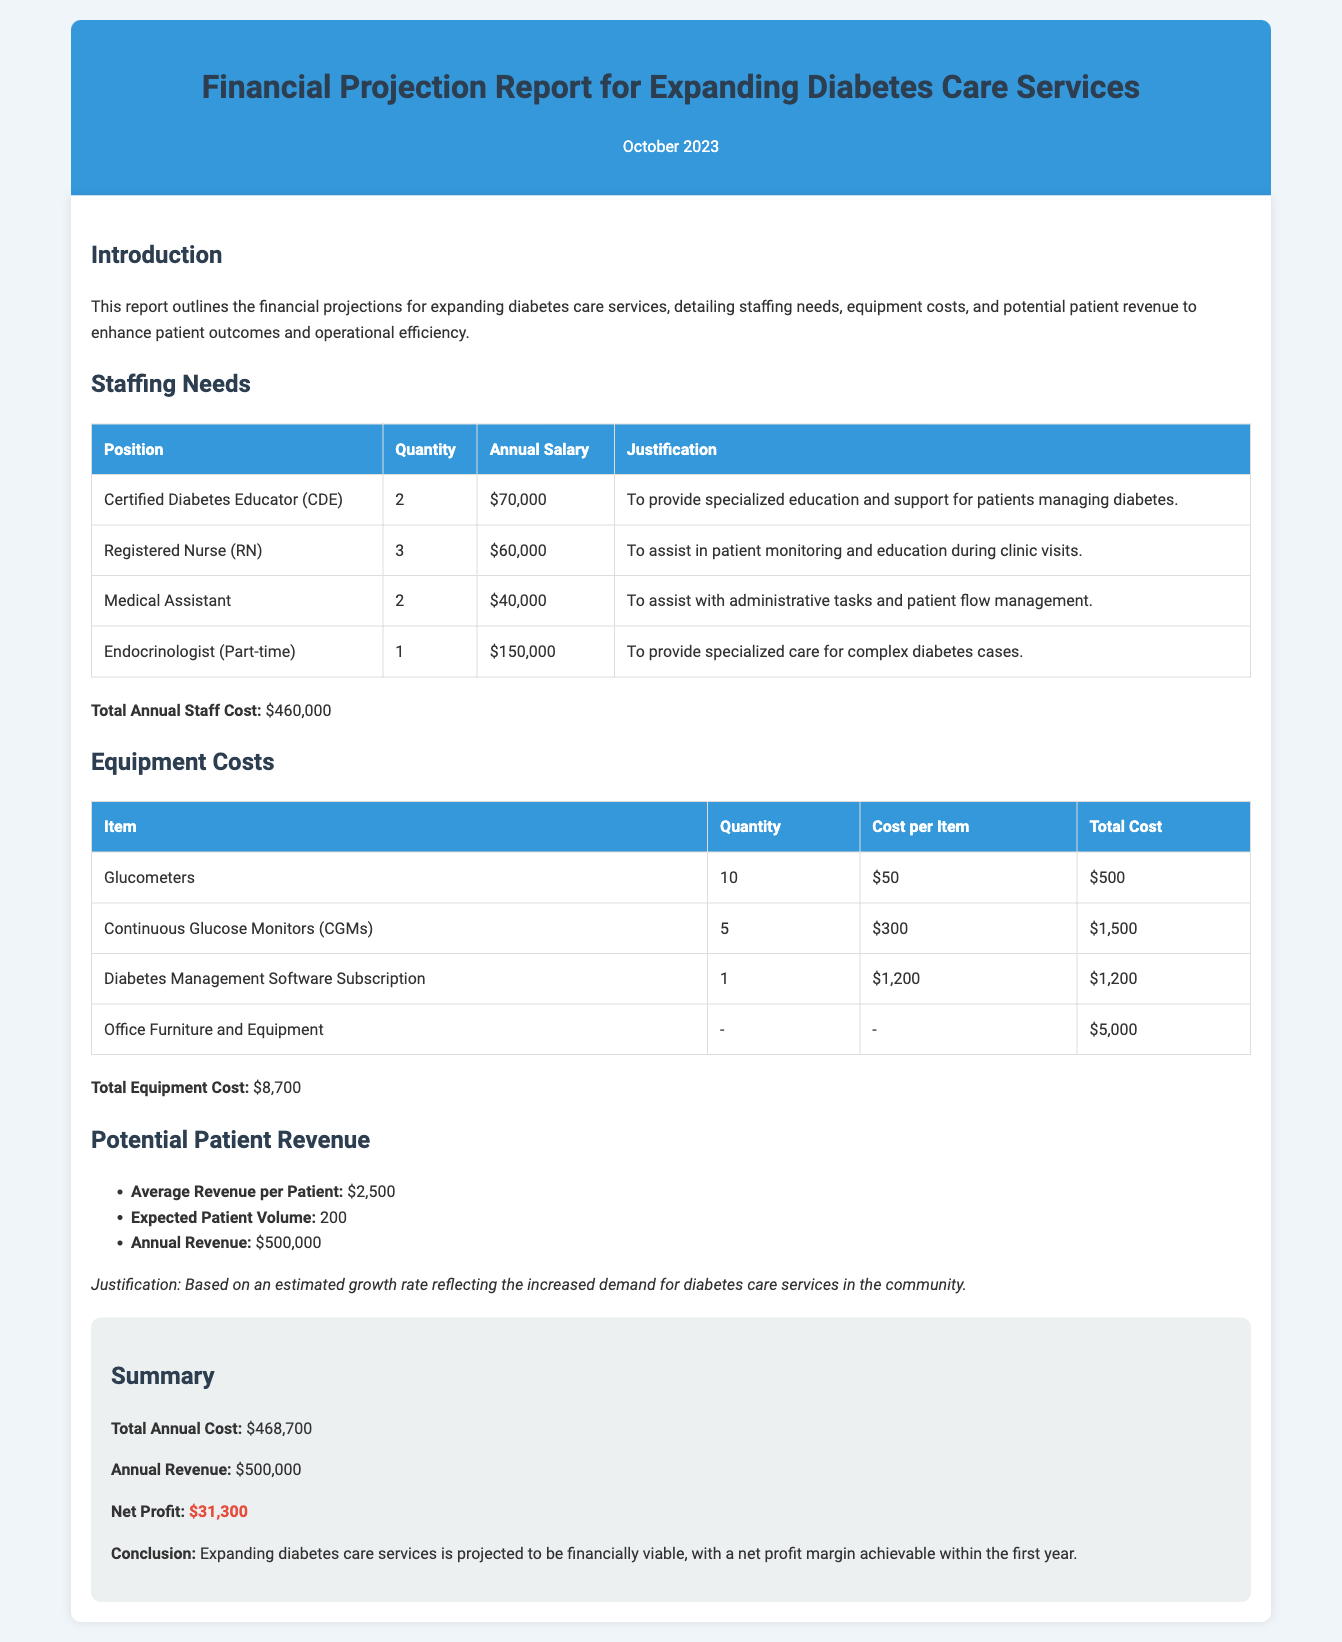What is the total annual staff cost? The total annual staff cost is calculated by adding the salaries of all staffing positions listed in the document.
Answer: $460,000 How many Certified Diabetes Educators are needed? The document states the quantity of Certified Diabetes Educators required for expanding diabetes care services.
Answer: 2 What is the total equipment cost? The total equipment cost is the sum of all individual equipment costs listed in the document.
Answer: $8,700 What is the expected annual revenue from patients? The expected annual revenue is stated directly in the potential patient revenue section of the document.
Answer: $500,000 What is the net profit projected for the first year? The net profit is calculated by subtracting the total annual cost from the annual revenue, as stated in the summary.
Answer: $31,300 What is the justification for hiring more staff? The justification for hiring staff is provided in the context of their roles and contributions to patient care and education.
Answer: To provide specialized education and support for patients managing diabetes How much does a Continuous Glucose Monitor cost? The cost of a Continuous Glucose Monitor is given as part of the equipment costs in the document.
Answer: $300 What is the average revenue per patient? The average revenue per patient is explicitly mentioned in the potential patient revenue section of the document.
Answer: $2,500 How many Registered Nurses are planned to be hired? The document specifies the planned quantity of Registered Nurses for the expanded services.
Answer: 3 What type of report is this document classified as? The document outlines financial projections for a specific type of healthcare service expansion.
Answer: Financial Projection Report 